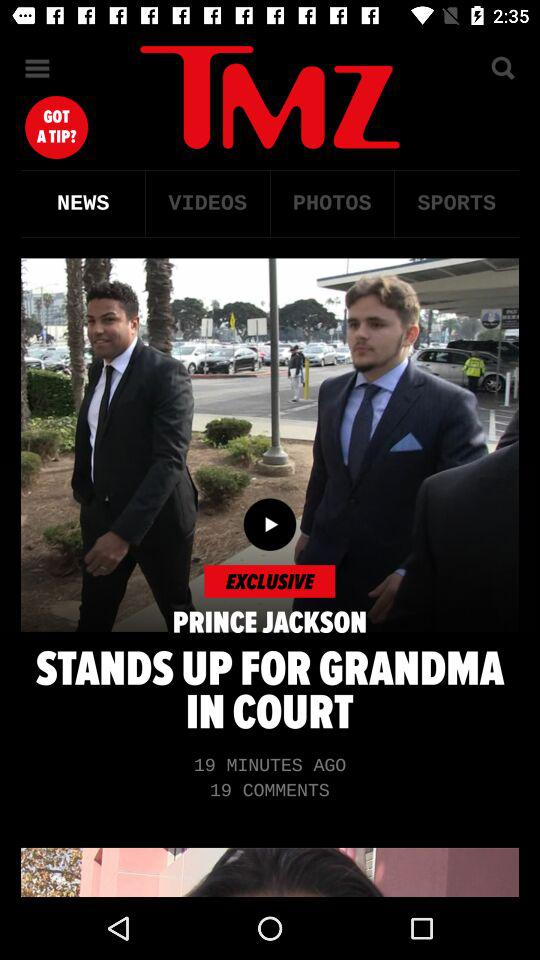How many comments are there on the article?
Answer the question using a single word or phrase. 19 